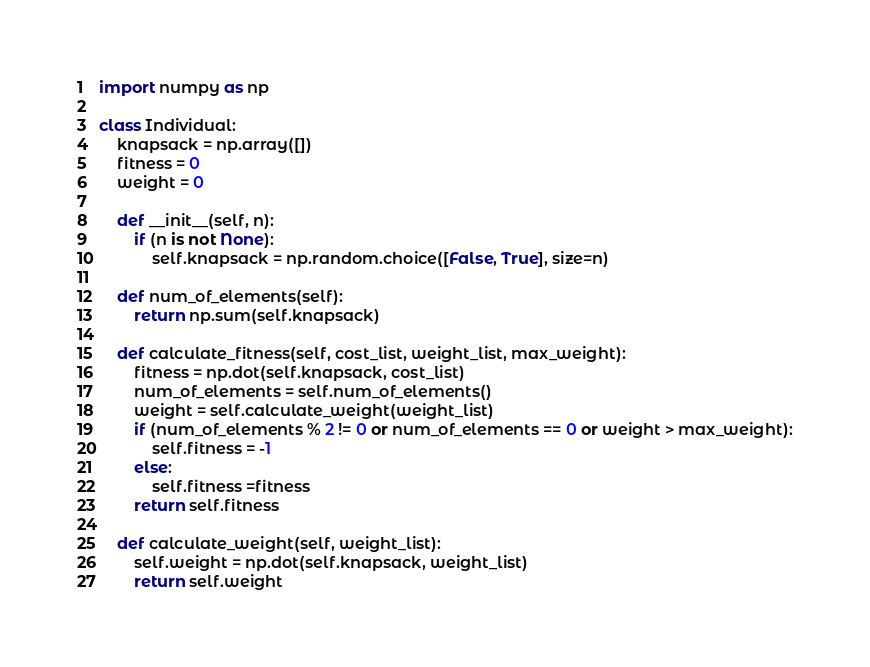Convert code to text. <code><loc_0><loc_0><loc_500><loc_500><_Python_>import numpy as np

class Individual:
    knapsack = np.array([])
    fitness = 0
    weight = 0

    def __init__(self, n):
        if (n is not None):
            self.knapsack = np.random.choice([False, True], size=n)
        
    def num_of_elements(self):
        return np.sum(self.knapsack)

    def calculate_fitness(self, cost_list, weight_list, max_weight):
        fitness = np.dot(self.knapsack, cost_list)
        num_of_elements = self.num_of_elements()
        weight = self.calculate_weight(weight_list)
        if (num_of_elements % 2 != 0 or num_of_elements == 0 or weight > max_weight):
            self.fitness = -1
        else:
            self.fitness =fitness
        return self.fitness

    def calculate_weight(self, weight_list):
        self.weight = np.dot(self.knapsack, weight_list)
        return self.weight</code> 